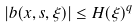<formula> <loc_0><loc_0><loc_500><loc_500>| b ( x , s , \xi ) | \leq H ( \xi ) ^ { q }</formula> 